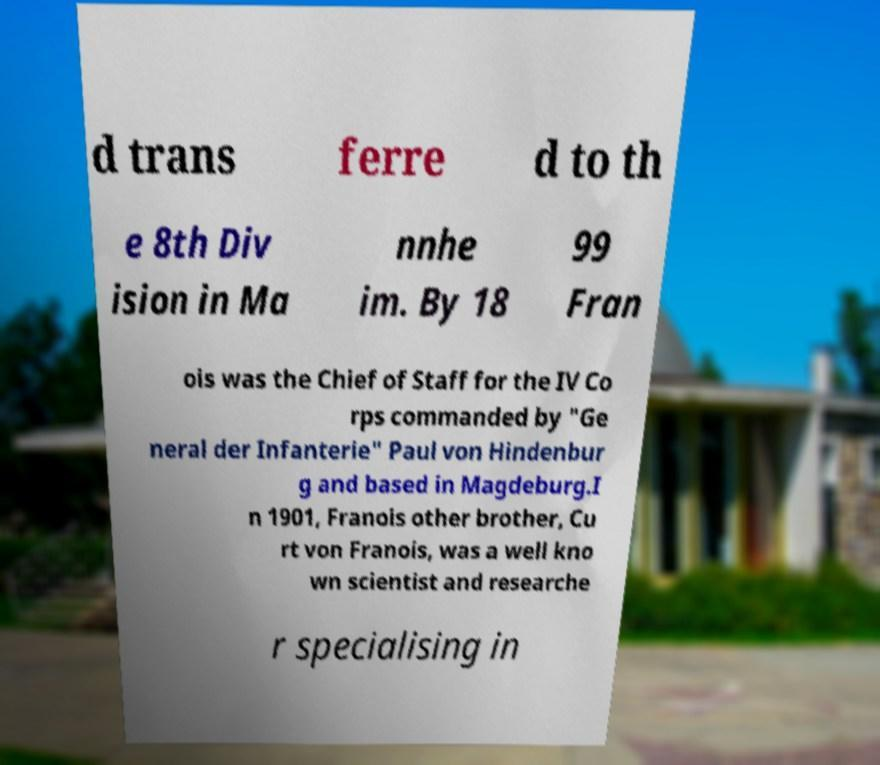I need the written content from this picture converted into text. Can you do that? d trans ferre d to th e 8th Div ision in Ma nnhe im. By 18 99 Fran ois was the Chief of Staff for the IV Co rps commanded by "Ge neral der Infanterie" Paul von Hindenbur g and based in Magdeburg.I n 1901, Franois other brother, Cu rt von Franois, was a well kno wn scientist and researche r specialising in 